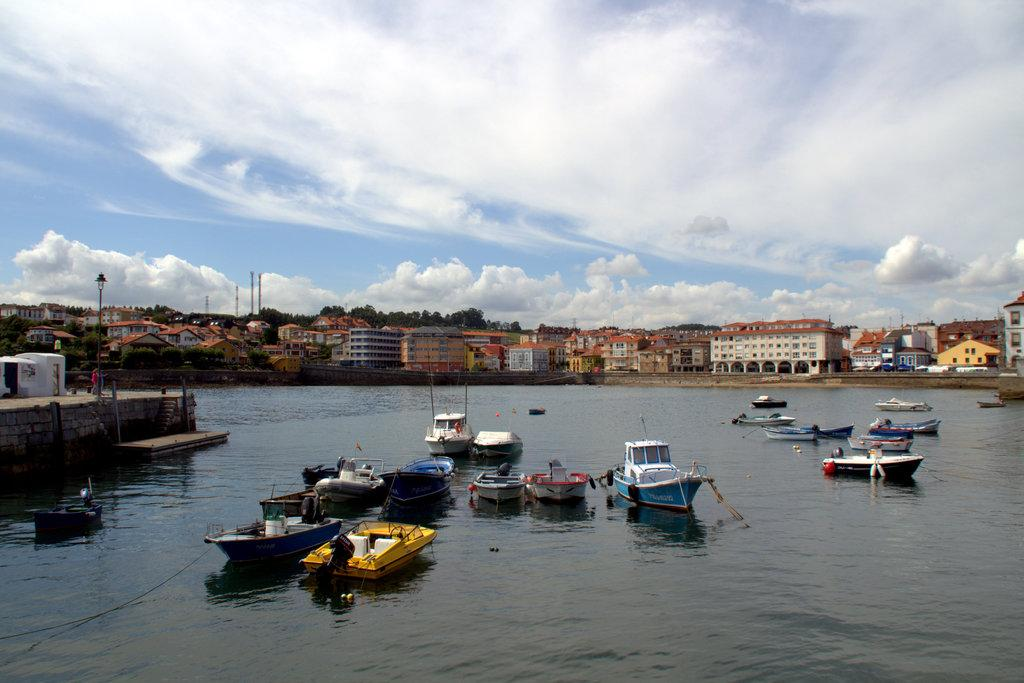What is the setting of the image? The image is an outside view. What can be seen on the water at the bottom of the image? There are boats on the water at the bottom of the image. What is visible in the background of the image? There are buildings and trees in the background of the image. What is visible at the top of the image? The sky is visible at the top of the image. What can be observed in the sky? Clouds are present in the sky. What type of company is offering a service to the people in the image? There is no company or service being offered in the image; it is a view of boats, buildings, trees, and the sky. Is there a lake visible in the image? There is no lake mentioned or visible in the image; it features boats on water, which could be a river or another body of water. 